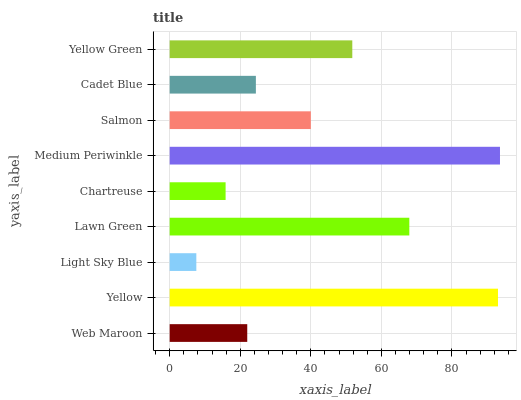Is Light Sky Blue the minimum?
Answer yes or no. Yes. Is Medium Periwinkle the maximum?
Answer yes or no. Yes. Is Yellow the minimum?
Answer yes or no. No. Is Yellow the maximum?
Answer yes or no. No. Is Yellow greater than Web Maroon?
Answer yes or no. Yes. Is Web Maroon less than Yellow?
Answer yes or no. Yes. Is Web Maroon greater than Yellow?
Answer yes or no. No. Is Yellow less than Web Maroon?
Answer yes or no. No. Is Salmon the high median?
Answer yes or no. Yes. Is Salmon the low median?
Answer yes or no. Yes. Is Yellow Green the high median?
Answer yes or no. No. Is Yellow Green the low median?
Answer yes or no. No. 